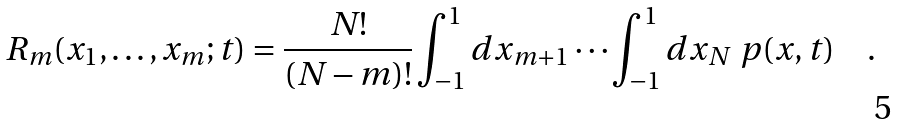Convert formula to latex. <formula><loc_0><loc_0><loc_500><loc_500>R _ { m } ( x _ { 1 } , \dots , x _ { m } ; t ) = \frac { N ! } { ( N - m ) ! } \int _ { - 1 } ^ { 1 } d x _ { m + 1 } \cdots \int _ { - 1 } ^ { 1 } d x _ { N } \ p ( x , t ) \quad .</formula> 